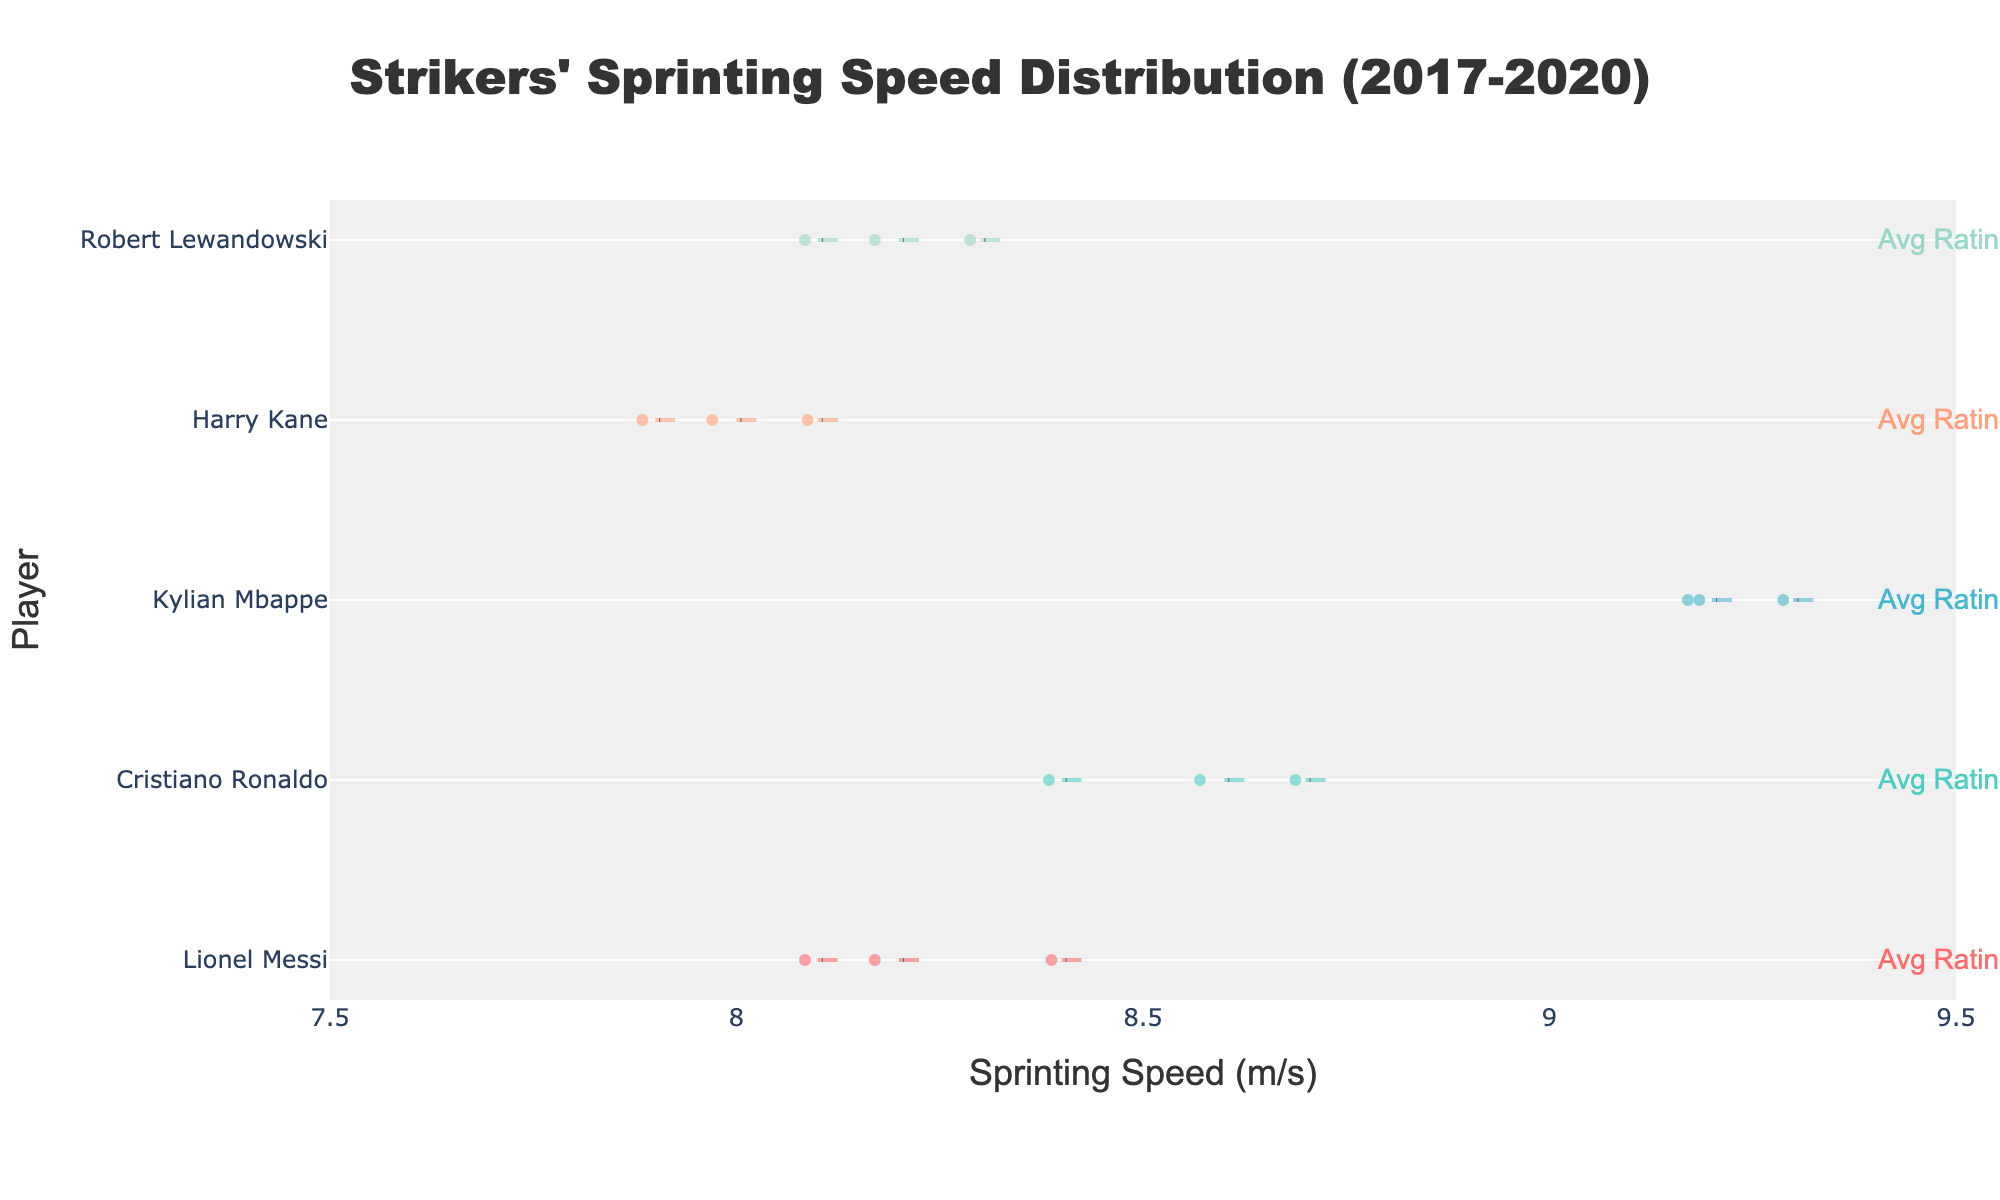what is the title of the chart? The title is located at the top of the chart. It provides a clear summary of the content the chart represents.
Answer: Strikers' Sprinting Speed Distribution (2017-2020) Who has the highest average sprinting speed? To find the highest average sprinting speed, visually locate the player whose violin plot extends furthest to the right.
Answer: Kylian Mbappe What's the average performance rating of Harry Kane? Check the annotation next to Harry Kane's violin plot, which indicates his average performance rating.
Answer: 8.5 Which player shows the widest variation in sprinting speed? A wider variation will be indicated by a more spread-out violin plot along the x-axis.
Answer: Kylian Mbappe Is there any player whose average sprinting speed remained almost the same over the seasons? Look for a player whose data points (dots) are closely clustered together along the x-axis.
Answer: Kylian Mbappe Which player had the most significant drop in sprinting speed between two seasons? Compare the positions of the data points for each player across seasons to see where the largest drop occurs.
Answer: Harry Kane (between 2018/2019 and 2019/2020) What's the average sprinting speed of Cristiano Ronaldo across seasons? Cristiano Ronaldo's average sprinting speed is reflected by the central thick line of his violin plot.
Answer: Approximately 8.6 m/s Between Lionel Messi and Robert Lewandowski, who has the higher average performance rating? Compare the annotations next to Messi and Lewandowski's violin plots that show their average performance ratings.
Answer: Robert Lewandowski What is the range of sprinting speed for Lionel Messi? Look at the extremes (minimum and maximum) of Lionel Messi's violin plot along the x-axis.
Answer: 8.1 to 8.4 m/s Which player’s sprinting speed decreased every season from 2017 to 2020? Analyze the data points for each player and notice if their sprinting speed consistently decreases over the three seasons.
Answer: Harry Kane 